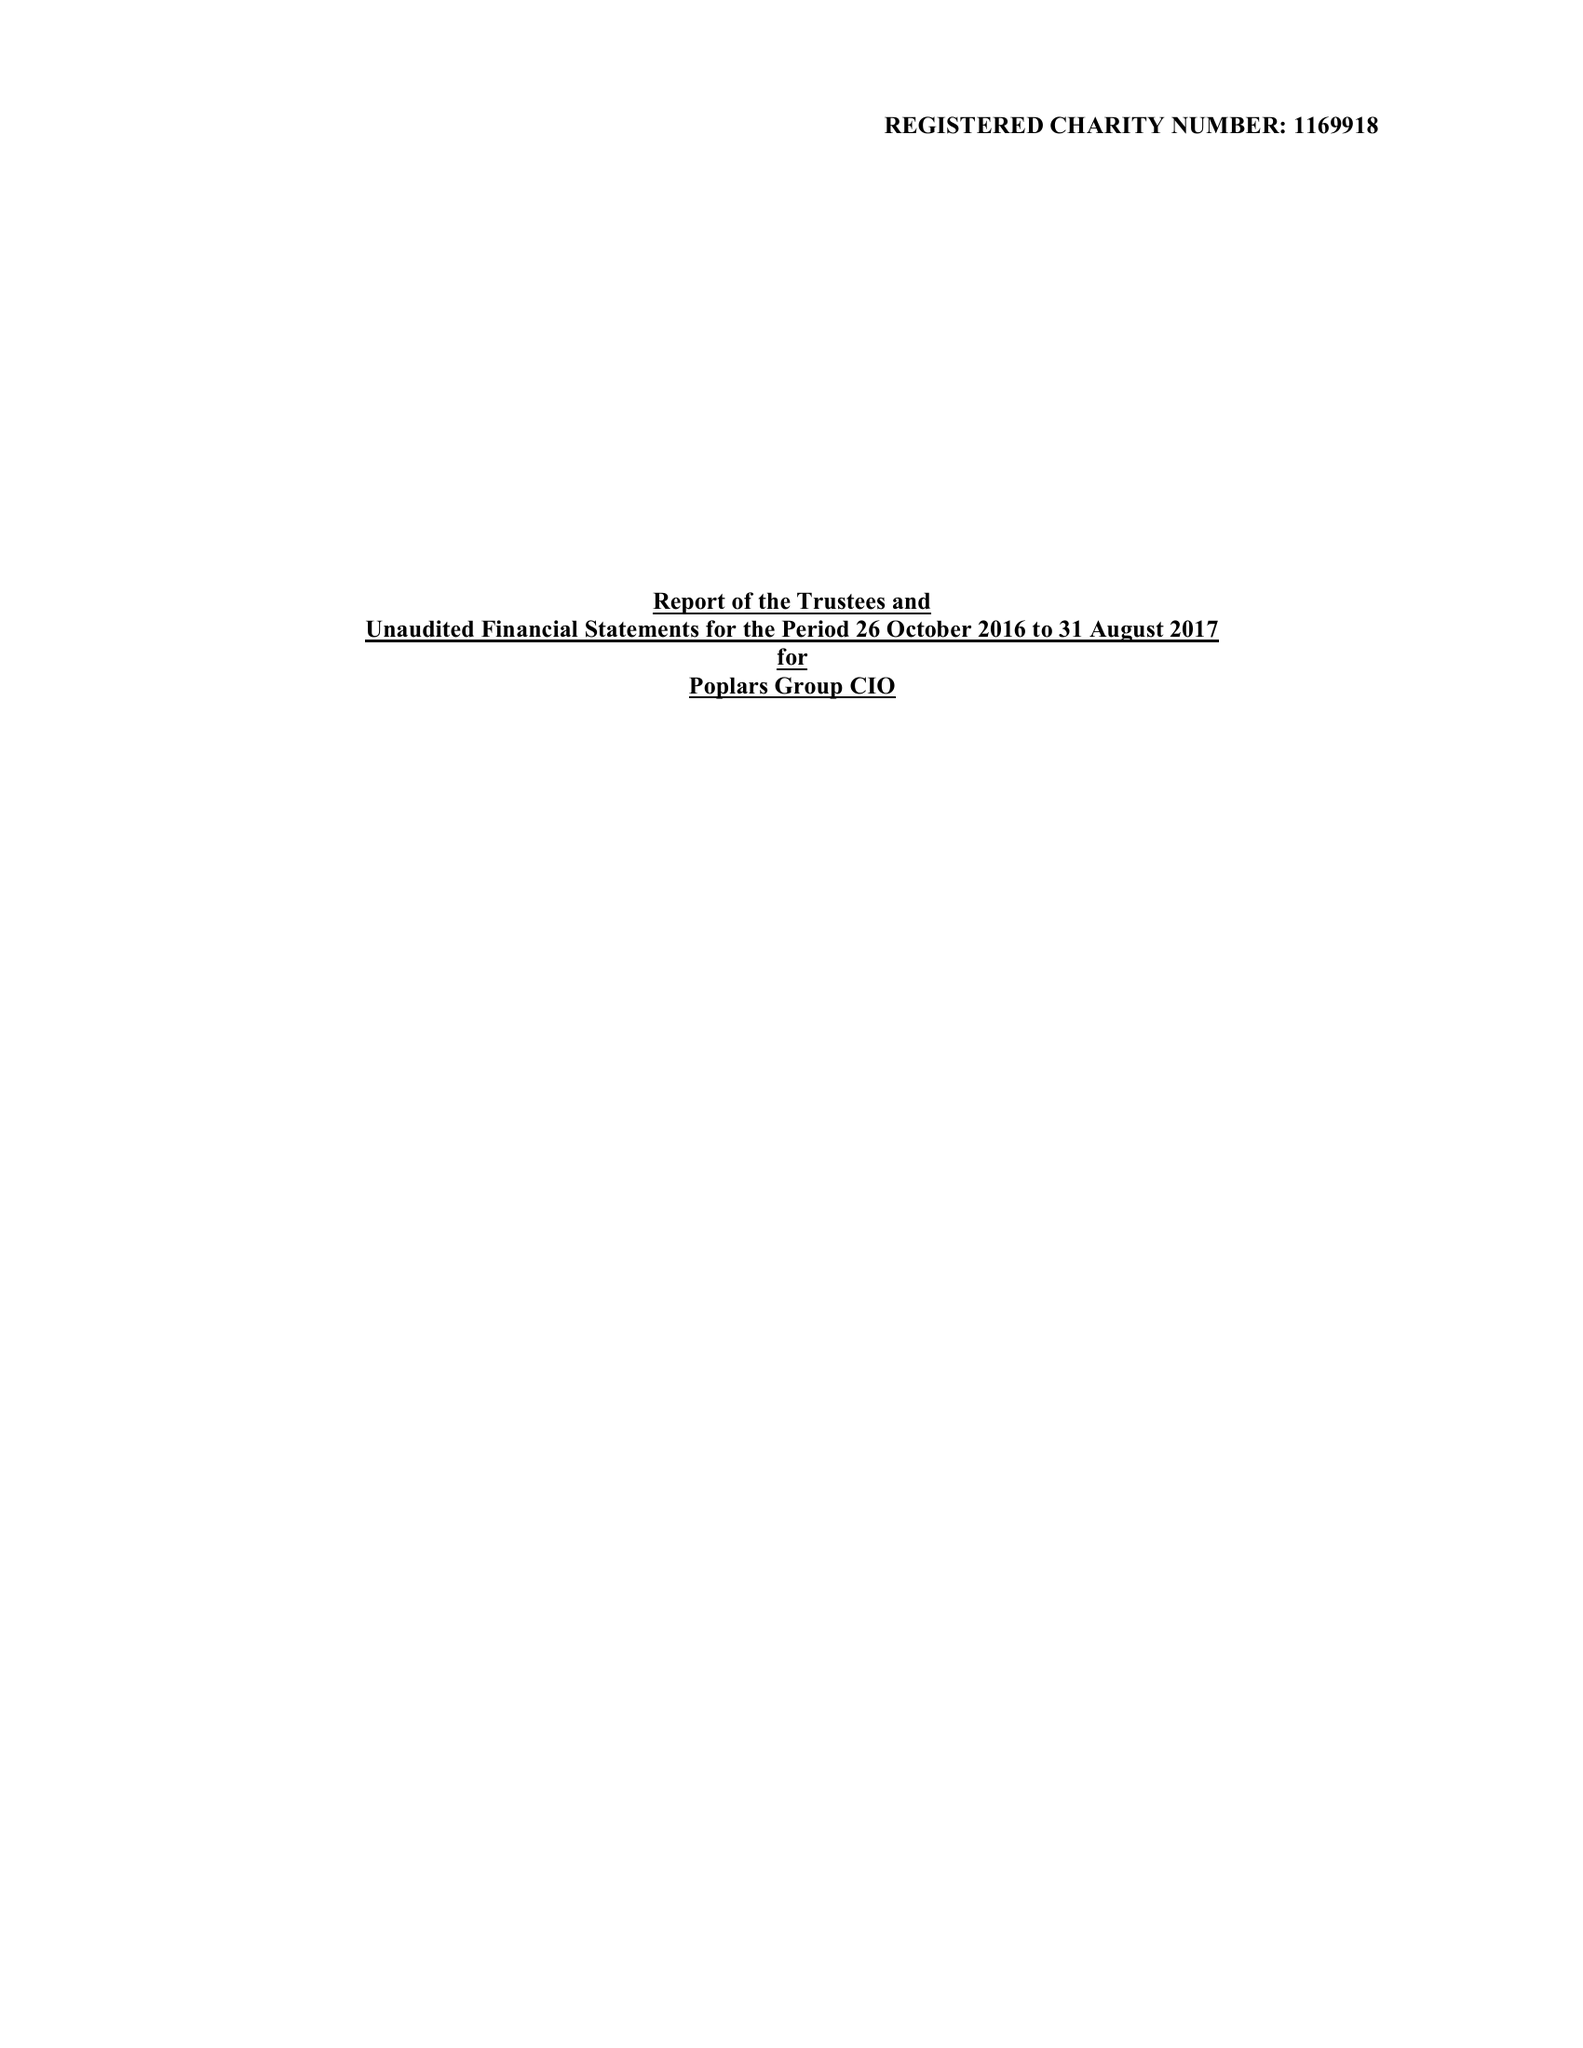What is the value for the report_date?
Answer the question using a single word or phrase. 2017-08-31 